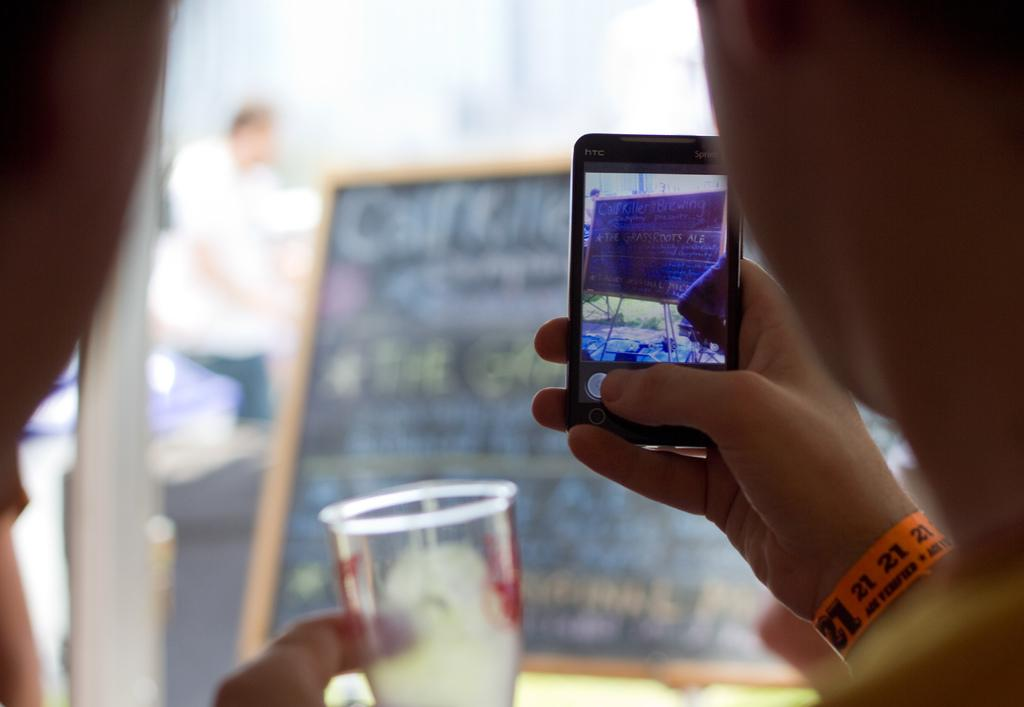<image>
Share a concise interpretation of the image provided. A person holding a smartphone as they take a picture with an orange band with written numbers 21 21 21 